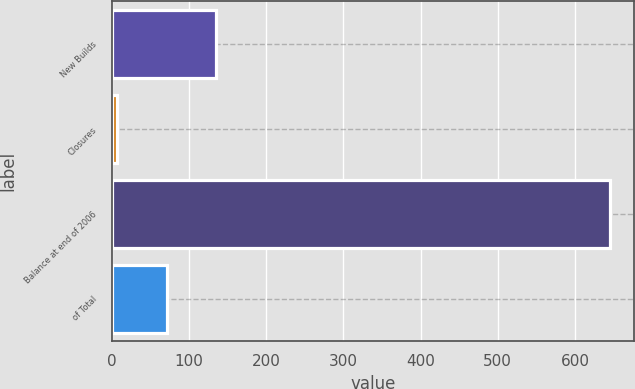<chart> <loc_0><loc_0><loc_500><loc_500><bar_chart><fcel>New Builds<fcel>Closures<fcel>Balance at end of 2006<fcel>of Total<nl><fcel>134.6<fcel>7<fcel>645<fcel>70.8<nl></chart> 